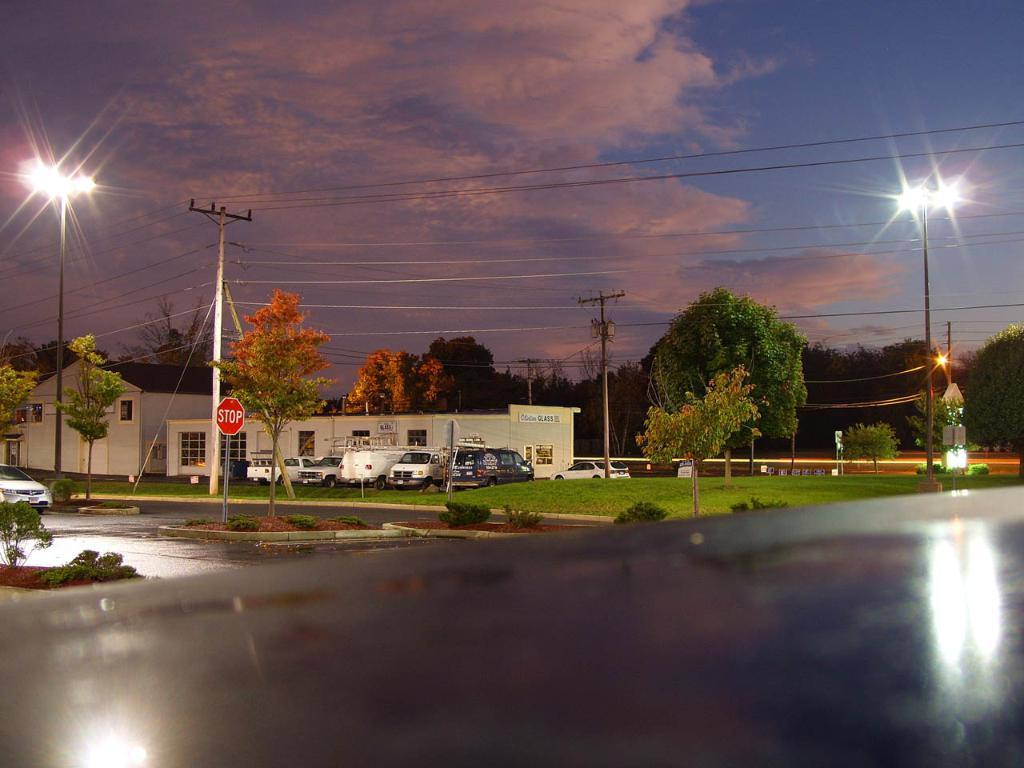What type of structures can be seen in the image? There are buildings in the image. What else is present in the image besides buildings? There are vehicles, poles, trees, grass on the ground, and plants in the image. What is the condition of the sky in the image? The sky is cloudy in the image. What flavor of tax is being discussed in the image? There is no discussion of tax or any flavor in the image. Who is the creator of the plants in the image? The image does not provide information about the creator of the plants; they are simply present in the scene. 